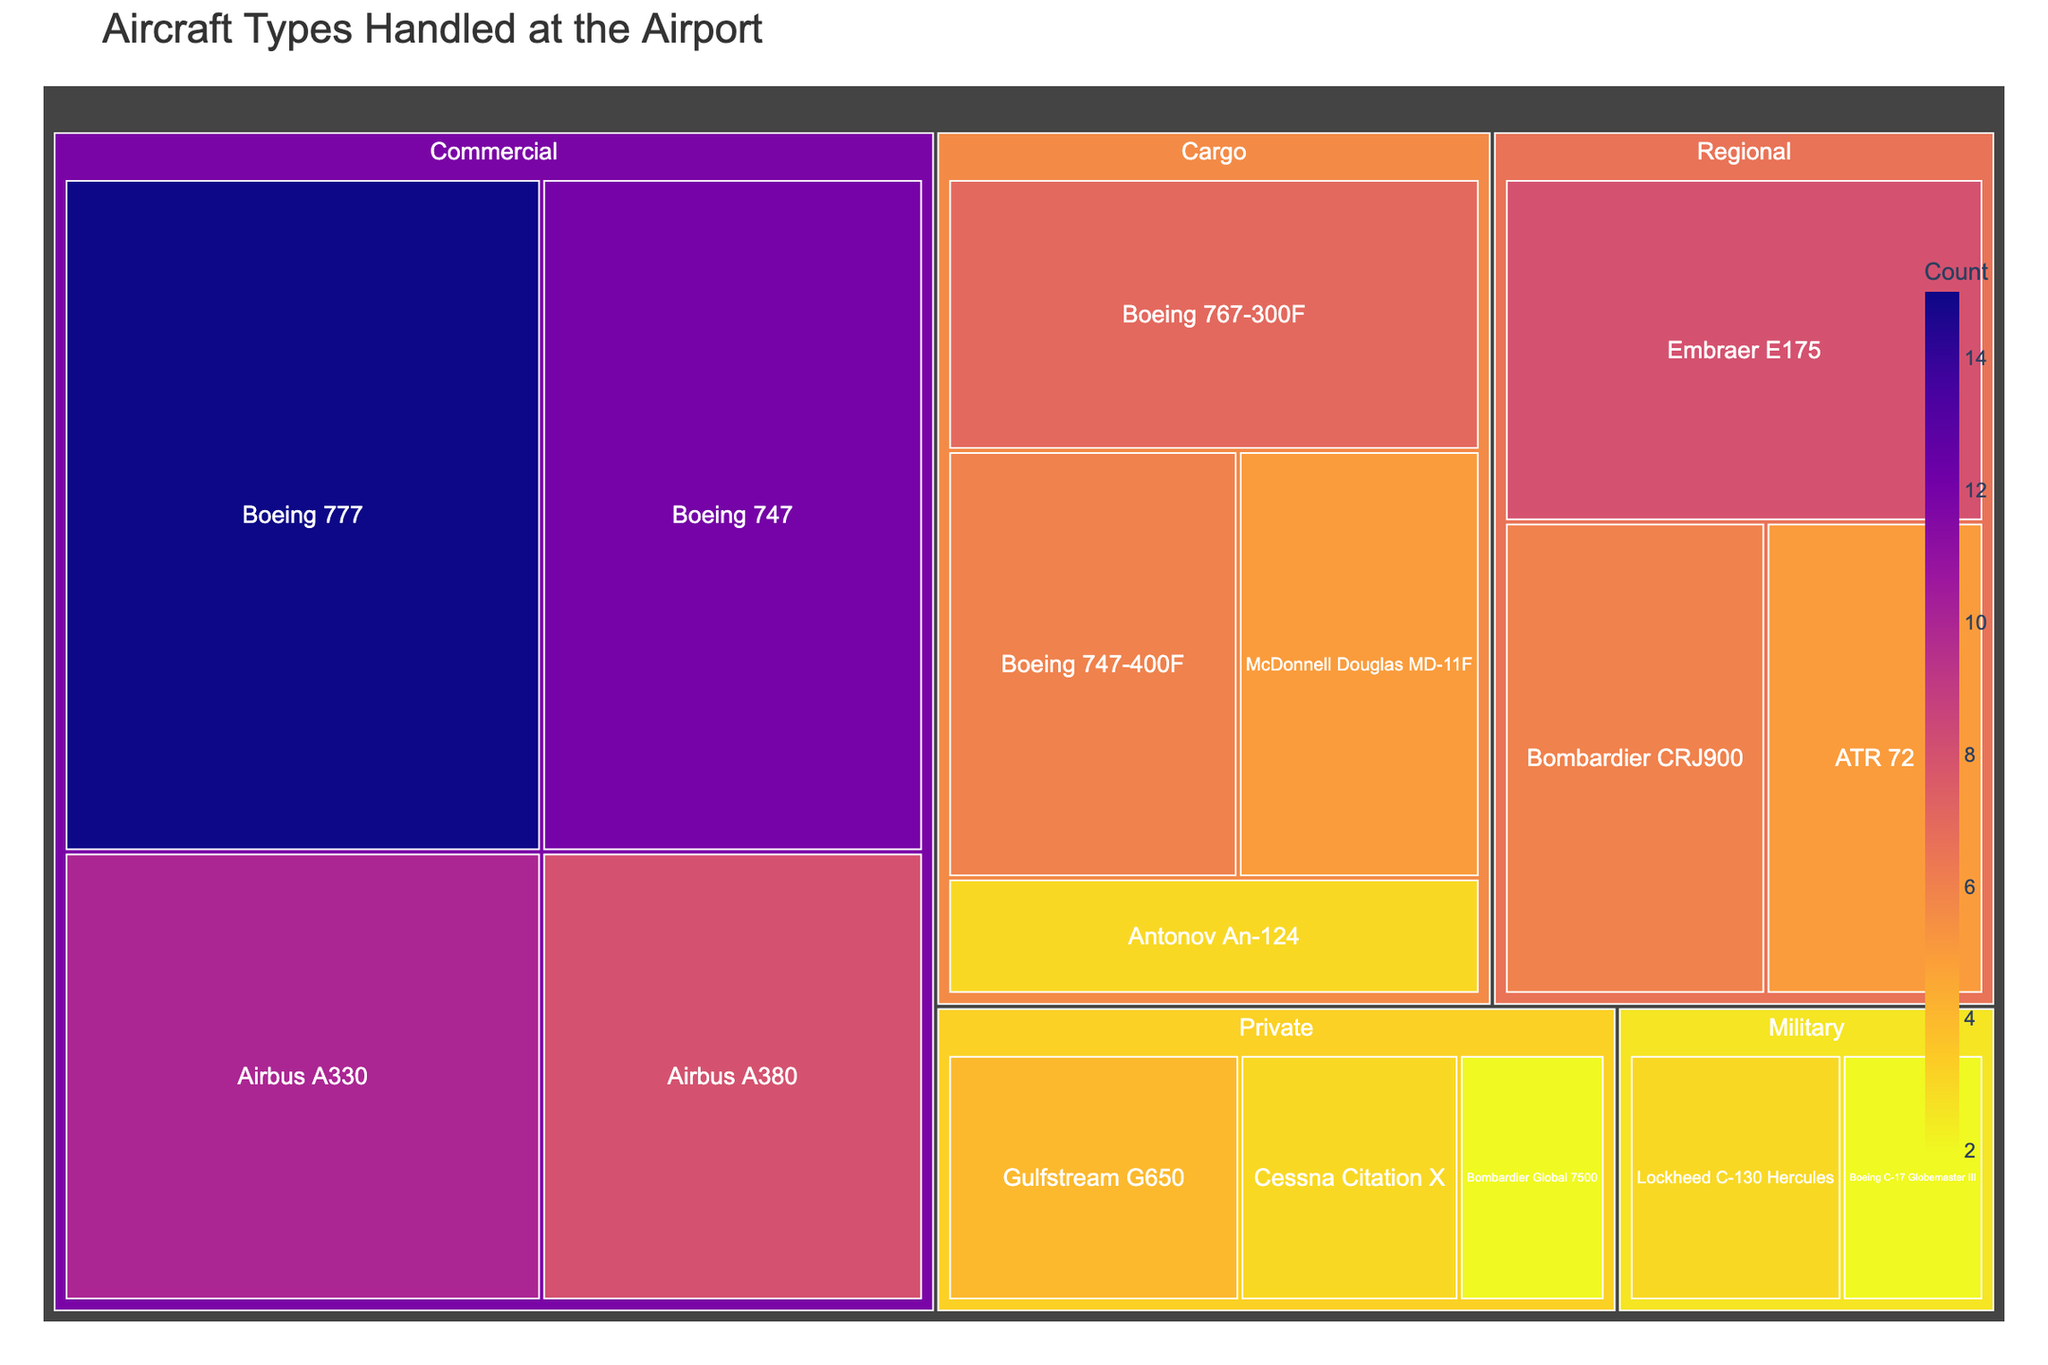what is the title of the figure? The title of the figure is prominently displayed at the top of the visualization. The information can be directly read from this part.
Answer: Aircraft Types Handled at the Airport Which aircraft type has the highest count in the Commercial category? Look under the “Commercial” category in the visualization. The size of the boxes is larger for higher counts, and the number is indicated within the box.
Answer: Boeing 777 How many aircraft types are represented in the Cargo category? Count the number of distinct boxes under the Cargo category in the treemap. Each distinct box represents a different type.
Answer: 4 What is the total count of Commercial aircraft types? Sum the counts of all the boxes under the Commercial category. Add the numbers inside each box for a total.
Answer: 12 + 8 + 15 + 10 = 45 Which type of aircraft is more common: Private or Military? Sum the counts of aircraft under both the “Private” and “Military” categories. Compare the totals. Military: 3+2=5; Private: 4+3+2=9; Compare 5 vs 9.
Answer: Private Which aircraft type has the smallest count among all categories? Look for the smallest box on the treemap and note the count indicated. Confirm by checking other counts to ensure it is the smallest one.
Answer: Bombardier Global 7500 How many categories have exactly 3 aircraft types? Count the categories where the number of distinct aircraft types (boxes) is exactly 3. For instance, see if there are three boxes under each relevant category.
Answer: 3 (Cargo, Private, Military) What is the total count of aircraft in the Regional category? Sum the counts of all aircraft types under the Regional category by adding the numbers from each box.
Answer: 8 + 6 + 5 = 19 Which aircraft type has the highest count in the Cargo category? Look under the “Cargo” category and identify which box has the highest number.
Answer: Boeing 767-300F How does the count of Gulfstream G650 compare to Antonov An-124? Identify the counts for both Gulfstream G650 and Antonov An-124 and compare them. Gulfstream G650: 4; Antonov An-124: 3.
Answer: Gulfstream G650 has a higher count by 1 